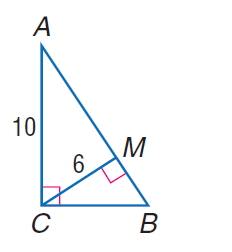Question: Find the perimeter of \triangle A B C.
Choices:
A. 20
B. 24
C. 30
D. 32
Answer with the letter. Answer: C 